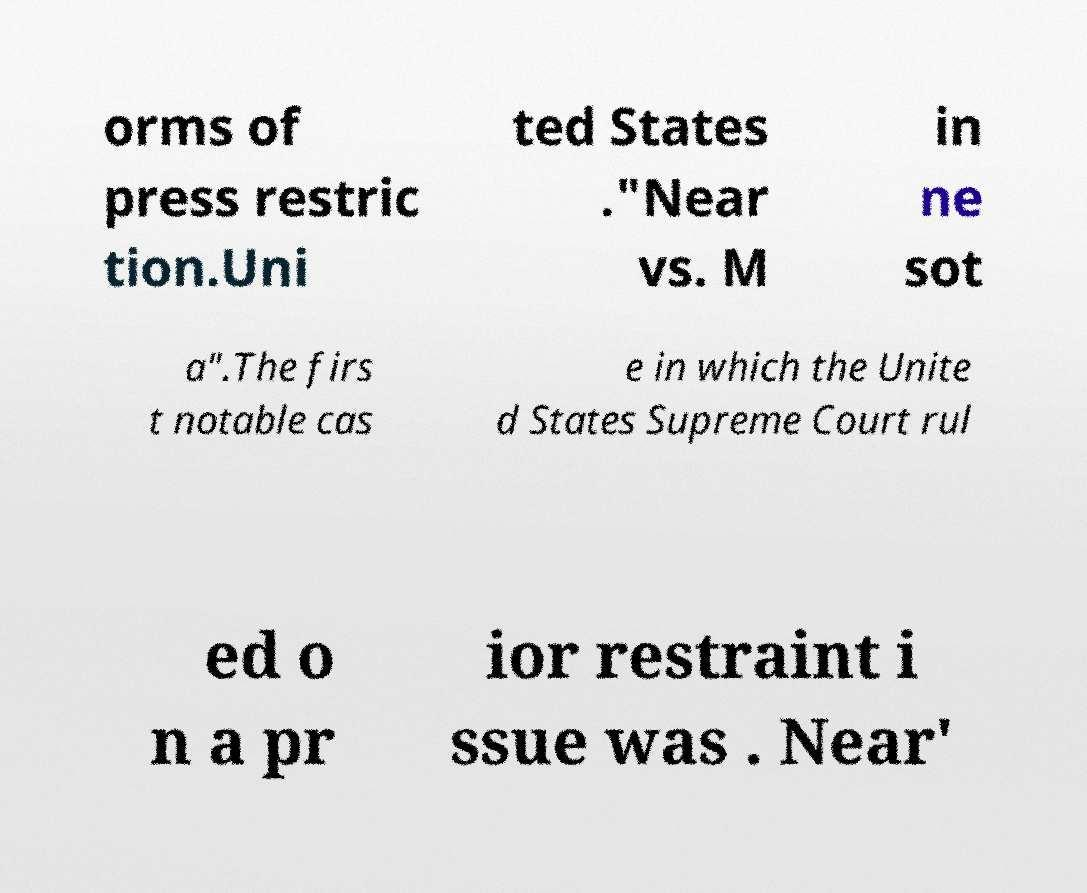What messages or text are displayed in this image? I need them in a readable, typed format. orms of press restric tion.Uni ted States ."Near vs. M in ne sot a".The firs t notable cas e in which the Unite d States Supreme Court rul ed o n a pr ior restraint i ssue was . Near' 